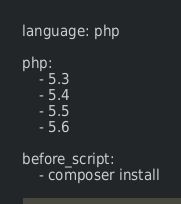<code> <loc_0><loc_0><loc_500><loc_500><_YAML_>language: php

php:
    - 5.3
    - 5.4
    - 5.5
    - 5.6

before_script:
    - composer install</code> 